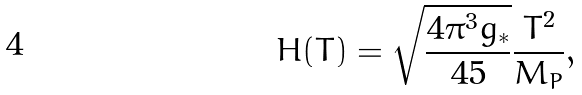<formula> <loc_0><loc_0><loc_500><loc_500>H ( T ) = \sqrt { \frac { 4 \pi ^ { 3 } g _ { \ast } } { 4 5 } } \frac { T ^ { 2 } } { M _ { P } } ,</formula> 